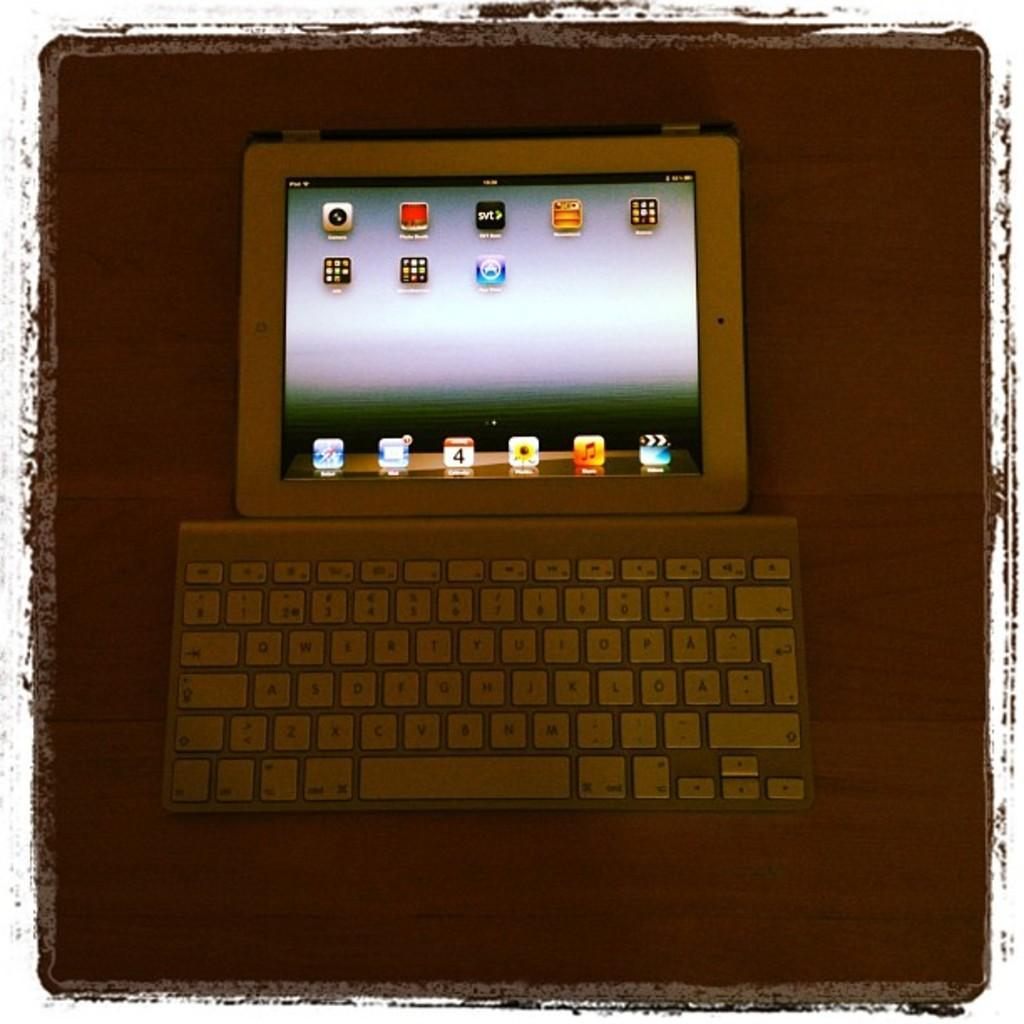What electronic device is visible in the image? There is a laptop in the image. What type of surface is the laptop placed on? The laptop is on a wooden surface. What type of pin is holding the laptop to the wooden surface? There is no pin visible in the image, and the laptop is not attached to the wooden surface. 